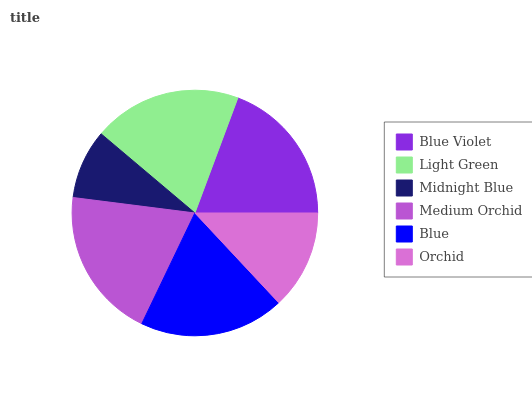Is Midnight Blue the minimum?
Answer yes or no. Yes. Is Medium Orchid the maximum?
Answer yes or no. Yes. Is Light Green the minimum?
Answer yes or no. No. Is Light Green the maximum?
Answer yes or no. No. Is Light Green greater than Blue Violet?
Answer yes or no. Yes. Is Blue Violet less than Light Green?
Answer yes or no. Yes. Is Blue Violet greater than Light Green?
Answer yes or no. No. Is Light Green less than Blue Violet?
Answer yes or no. No. Is Blue Violet the high median?
Answer yes or no. Yes. Is Blue the low median?
Answer yes or no. Yes. Is Midnight Blue the high median?
Answer yes or no. No. Is Orchid the low median?
Answer yes or no. No. 